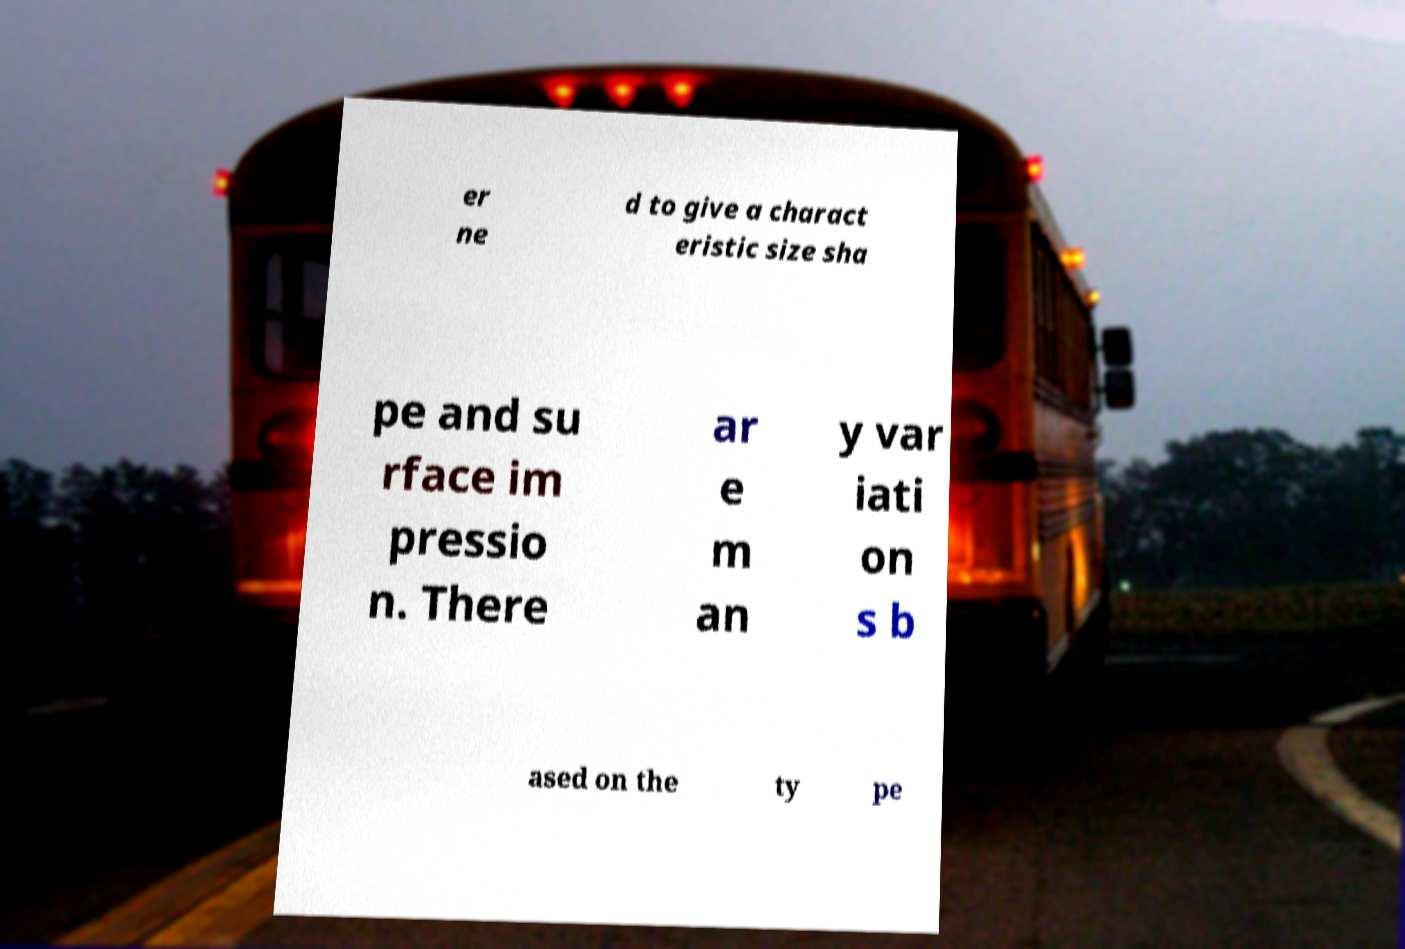Could you assist in decoding the text presented in this image and type it out clearly? er ne d to give a charact eristic size sha pe and su rface im pressio n. There ar e m an y var iati on s b ased on the ty pe 